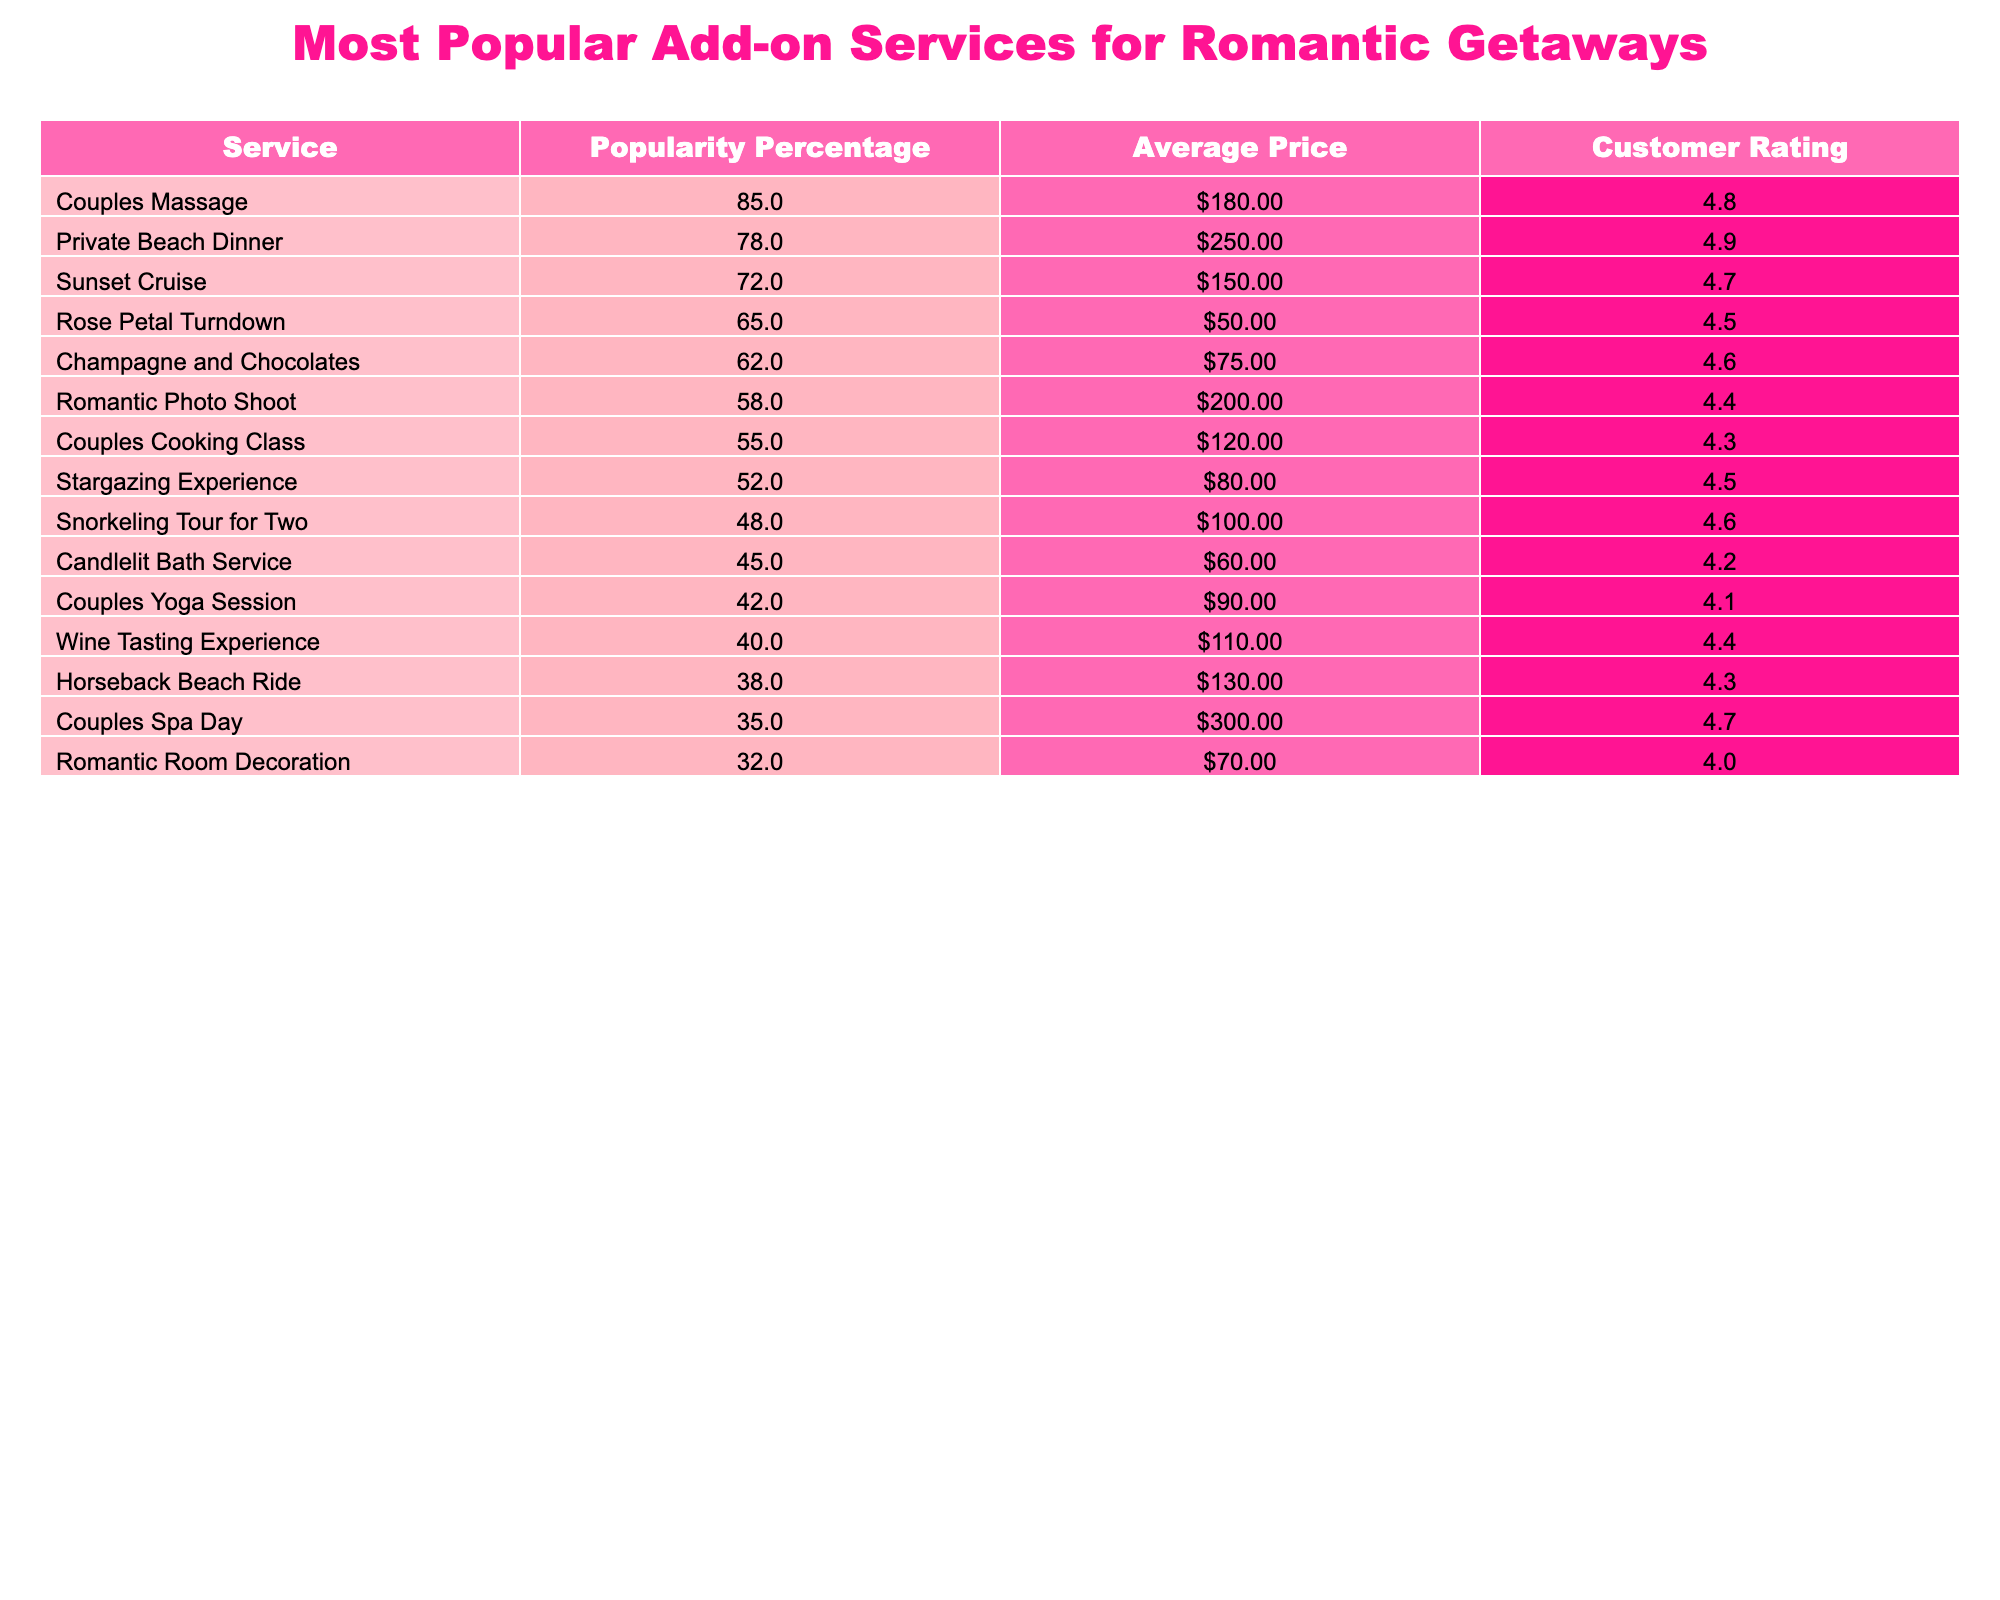What is the most popular add-on service for romantic getaways? The highest popularity percentage listed in the table is 85% for Couples Massage.
Answer: Couples Massage How much does a Private Beach Dinner cost on average? The table shows the Average Price for Private Beach Dinner is $250.
Answer: $250 Which service has the highest customer rating? The service with the highest customer rating at 4.9 is Private Beach Dinner.
Answer: Private Beach Dinner How many services have a popularity percentage greater than 70%? The services with a popularity percentage greater than 70% are Couples Massage, Private Beach Dinner, and Sunset Cruise, totaling three services.
Answer: 3 What is the average price of the top three most popular services? The prices of the top three most popular services are $180, $250, and $150. The total is $180 + $250 + $150 = $580, and the average is $580 / 3 = $193.33.
Answer: $193.33 Is the customer rating for the Couples Cooking Class higher than the average rating of all services? The customer rating for Couples Cooking Class is 4.3, and we need to calculate the average of all ratings by summing them and dividing by the number of services. The total is (4.8 + 4.9 + 4.7 + 4.5 + 4.6 + 4.4 + 4.3 + 4.5 + 4.6 + 4.2 + 4.1 + 4.4 + 4.3 + 4.0) = 64.4, divided by 14 gives an average of approximately 4.6. Since 4.3 is less than 4.6, the answer is no.
Answer: No What is the difference in average price between the Couples Spa Day and the Rose Petal Turndown? Couples Spa Day costs $300 and Rose Petal Turndown costs $50. The difference is $300 - $50 = $250.
Answer: $250 Which service has a popularity percentage closest to the average popularity of all services? First, we need to calculate the average popularity percentage which is (85% + 78% + 72% + 65% + 62% + 58% + 55% + 52% + 48% + 45% + 42% + 40% + 38% + 32%) / 14 = 56.14%. The service closest to this average is Couples Yoga Session at 42%.
Answer: Couples Yoga Session How many services have both customer ratings and popularity percentage above 60%? The services exceeding 60% in popularity percentage are Couples Massage, Private Beach Dinner, Rose Petal Turndown, and Champagne and Chocolates, which are four services, all of which also have ratings above 4.0.
Answer: 4 Which service is the least popular among those listed? The service with the lowest popularity percentage listed in the table is Romantic Room Decoration with 32%.
Answer: Romantic Room Decoration 